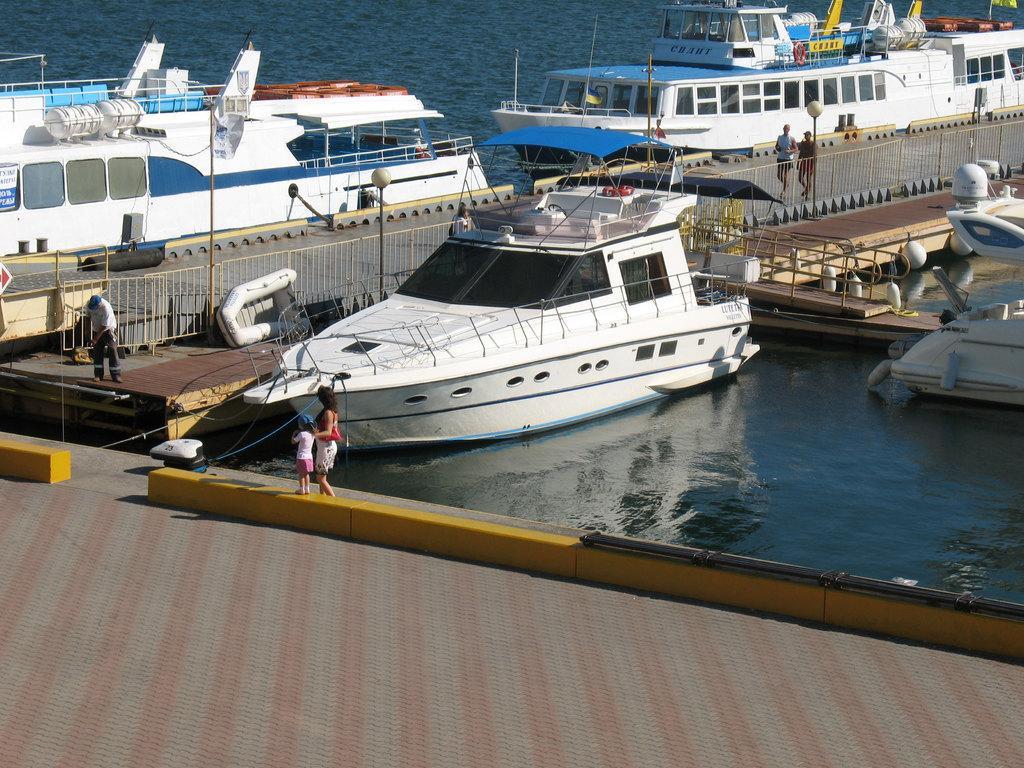Can you describe this image briefly? There are many boats with windows on the water. There is deck with railings. Also there are few people. There is a road. On the side of the road there are light poles. 